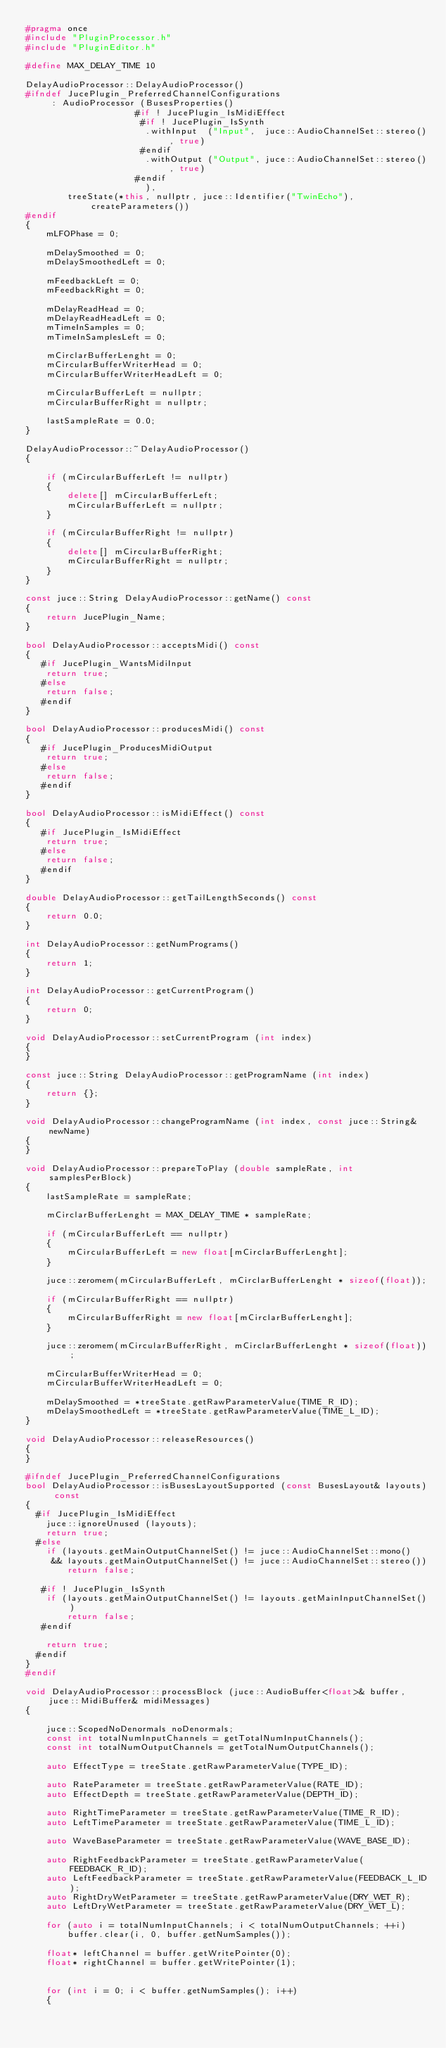Convert code to text. <code><loc_0><loc_0><loc_500><loc_500><_C++_>#pragma once
#include "PluginProcessor.h"
#include "PluginEditor.h"

#define MAX_DELAY_TIME 10

DelayAudioProcessor::DelayAudioProcessor()
#ifndef JucePlugin_PreferredChannelConfigurations
     : AudioProcessor (BusesProperties()
                     #if ! JucePlugin_IsMidiEffect
                      #if ! JucePlugin_IsSynth
                       .withInput  ("Input",  juce::AudioChannelSet::stereo(), true)
                      #endif
                       .withOutput ("Output", juce::AudioChannelSet::stereo(), true)
                     #endif
                       ),
        treeState(*this, nullptr, juce::Identifier("TwinEcho"), createParameters())
#endif
{
    mLFOPhase = 0;

    mDelaySmoothed = 0;
    mDelaySmoothedLeft = 0;

    mFeedbackLeft = 0;
    mFeedbackRight = 0;

    mDelayReadHead = 0;
    mDelayReadHeadLeft = 0;
    mTimeInSamples = 0;
    mTimeInSamplesLeft = 0;

    mCirclarBufferLenght = 0;
    mCircularBufferWriterHead = 0;
    mCircularBufferWriterHeadLeft = 0;

    mCircularBufferLeft = nullptr;
    mCircularBufferRight = nullptr;

    lastSampleRate = 0.0;
}

DelayAudioProcessor::~DelayAudioProcessor()
{

    if (mCircularBufferLeft != nullptr)
    {
        delete[] mCircularBufferLeft;
        mCircularBufferLeft = nullptr;
    }

    if (mCircularBufferRight != nullptr)
    {
        delete[] mCircularBufferRight;
        mCircularBufferRight = nullptr;
    }
}

const juce::String DelayAudioProcessor::getName() const
{
    return JucePlugin_Name;
}

bool DelayAudioProcessor::acceptsMidi() const
{
   #if JucePlugin_WantsMidiInput
    return true;
   #else
    return false;
   #endif
}

bool DelayAudioProcessor::producesMidi() const
{
   #if JucePlugin_ProducesMidiOutput
    return true;
   #else
    return false;
   #endif
}

bool DelayAudioProcessor::isMidiEffect() const
{
   #if JucePlugin_IsMidiEffect
    return true;
   #else
    return false;
   #endif
}

double DelayAudioProcessor::getTailLengthSeconds() const
{
    return 0.0;
}

int DelayAudioProcessor::getNumPrograms()
{
    return 1;
}

int DelayAudioProcessor::getCurrentProgram()
{
    return 0;
}

void DelayAudioProcessor::setCurrentProgram (int index)
{
}

const juce::String DelayAudioProcessor::getProgramName (int index)
{
    return {};
}

void DelayAudioProcessor::changeProgramName (int index, const juce::String& newName)
{
}

void DelayAudioProcessor::prepareToPlay (double sampleRate, int samplesPerBlock)
{
    lastSampleRate = sampleRate;

    mCirclarBufferLenght = MAX_DELAY_TIME * sampleRate;

    if (mCircularBufferLeft == nullptr)
    {
        mCircularBufferLeft = new float[mCirclarBufferLenght];
    }

    juce::zeromem(mCircularBufferLeft, mCirclarBufferLenght * sizeof(float));

    if (mCircularBufferRight == nullptr)
    {
        mCircularBufferRight = new float[mCirclarBufferLenght];
    }

    juce::zeromem(mCircularBufferRight, mCirclarBufferLenght * sizeof(float));

    mCircularBufferWriterHead = 0;
    mCircularBufferWriterHeadLeft = 0;

    mDelaySmoothed = *treeState.getRawParameterValue(TIME_R_ID);
    mDelaySmoothedLeft = *treeState.getRawParameterValue(TIME_L_ID);
}

void DelayAudioProcessor::releaseResources()
{
}

#ifndef JucePlugin_PreferredChannelConfigurations
bool DelayAudioProcessor::isBusesLayoutSupported (const BusesLayout& layouts) const
{
  #if JucePlugin_IsMidiEffect
    juce::ignoreUnused (layouts);
    return true;
  #else
    if (layouts.getMainOutputChannelSet() != juce::AudioChannelSet::mono()
     && layouts.getMainOutputChannelSet() != juce::AudioChannelSet::stereo())
        return false;

   #if ! JucePlugin_IsSynth
    if (layouts.getMainOutputChannelSet() != layouts.getMainInputChannelSet())
        return false;
   #endif

    return true;
  #endif
}
#endif

void DelayAudioProcessor::processBlock (juce::AudioBuffer<float>& buffer, juce::MidiBuffer& midiMessages)
{

    juce::ScopedNoDenormals noDenormals;
    const int totalNumInputChannels = getTotalNumInputChannels();
    const int totalNumOutputChannels = getTotalNumOutputChannels();

    auto EffectType = treeState.getRawParameterValue(TYPE_ID);

    auto RateParameter = treeState.getRawParameterValue(RATE_ID);
    auto EffectDepth = treeState.getRawParameterValue(DEPTH_ID);

    auto RightTimeParameter = treeState.getRawParameterValue(TIME_R_ID);
    auto LeftTimeParameter = treeState.getRawParameterValue(TIME_L_ID);

    auto WaveBaseParameter = treeState.getRawParameterValue(WAVE_BASE_ID);

    auto RightFeedbackParameter = treeState.getRawParameterValue(FEEDBACK_R_ID);
    auto LeftFeedbackParameter = treeState.getRawParameterValue(FEEDBACK_L_ID);
    auto RightDryWetParameter = treeState.getRawParameterValue(DRY_WET_R);
    auto LeftDryWetParameter = treeState.getRawParameterValue(DRY_WET_L);

    for (auto i = totalNumInputChannels; i < totalNumOutputChannels; ++i)
        buffer.clear(i, 0, buffer.getNumSamples());

    float* leftChannel = buffer.getWritePointer(0);
    float* rightChannel = buffer.getWritePointer(1);


    for (int i = 0; i < buffer.getNumSamples(); i++)
    {</code> 